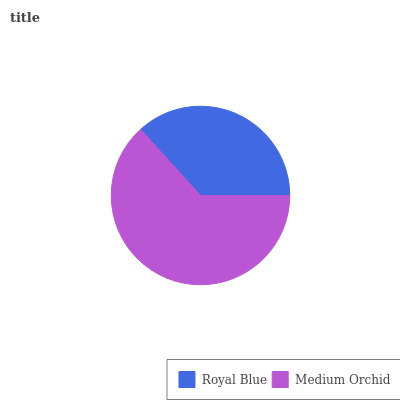Is Royal Blue the minimum?
Answer yes or no. Yes. Is Medium Orchid the maximum?
Answer yes or no. Yes. Is Medium Orchid the minimum?
Answer yes or no. No. Is Medium Orchid greater than Royal Blue?
Answer yes or no. Yes. Is Royal Blue less than Medium Orchid?
Answer yes or no. Yes. Is Royal Blue greater than Medium Orchid?
Answer yes or no. No. Is Medium Orchid less than Royal Blue?
Answer yes or no. No. Is Medium Orchid the high median?
Answer yes or no. Yes. Is Royal Blue the low median?
Answer yes or no. Yes. Is Royal Blue the high median?
Answer yes or no. No. Is Medium Orchid the low median?
Answer yes or no. No. 